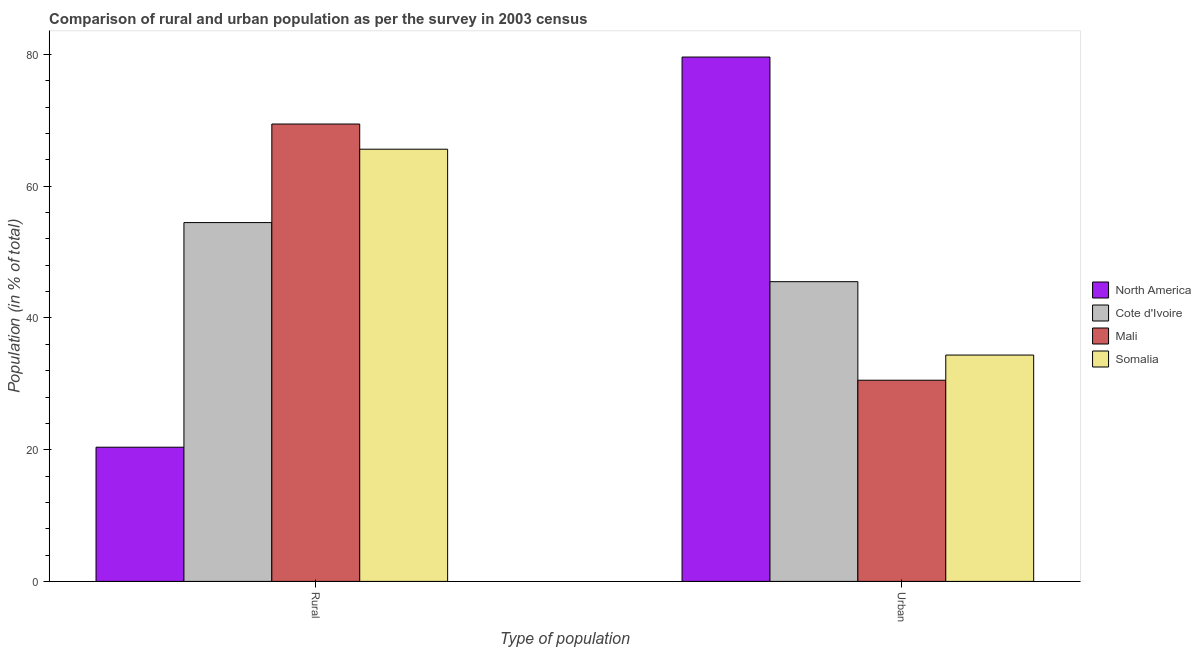Are the number of bars per tick equal to the number of legend labels?
Make the answer very short. Yes. Are the number of bars on each tick of the X-axis equal?
Make the answer very short. Yes. How many bars are there on the 1st tick from the left?
Your answer should be compact. 4. What is the label of the 2nd group of bars from the left?
Your answer should be very brief. Urban. What is the rural population in Cote d'Ivoire?
Provide a short and direct response. 54.49. Across all countries, what is the maximum rural population?
Provide a short and direct response. 69.45. Across all countries, what is the minimum urban population?
Give a very brief answer. 30.55. In which country was the rural population maximum?
Make the answer very short. Mali. In which country was the rural population minimum?
Provide a succinct answer. North America. What is the total rural population in the graph?
Provide a succinct answer. 209.94. What is the difference between the rural population in Mali and that in North America?
Provide a succinct answer. 49.08. What is the difference between the rural population in North America and the urban population in Mali?
Make the answer very short. -10.17. What is the average rural population per country?
Keep it short and to the point. 52.49. What is the difference between the rural population and urban population in Mali?
Your answer should be compact. 38.91. In how many countries, is the rural population greater than 48 %?
Provide a short and direct response. 3. What is the ratio of the urban population in Mali to that in Somalia?
Your response must be concise. 0.89. Is the rural population in Somalia less than that in Mali?
Make the answer very short. Yes. In how many countries, is the rural population greater than the average rural population taken over all countries?
Provide a succinct answer. 3. What does the 1st bar from the right in Urban represents?
Your answer should be very brief. Somalia. How many countries are there in the graph?
Ensure brevity in your answer.  4. What is the difference between two consecutive major ticks on the Y-axis?
Offer a terse response. 20. Does the graph contain any zero values?
Keep it short and to the point. No. What is the title of the graph?
Your answer should be compact. Comparison of rural and urban population as per the survey in 2003 census. What is the label or title of the X-axis?
Offer a terse response. Type of population. What is the label or title of the Y-axis?
Your response must be concise. Population (in % of total). What is the Population (in % of total) in North America in Rural?
Offer a terse response. 20.38. What is the Population (in % of total) in Cote d'Ivoire in Rural?
Offer a very short reply. 54.49. What is the Population (in % of total) in Mali in Rural?
Keep it short and to the point. 69.45. What is the Population (in % of total) in Somalia in Rural?
Make the answer very short. 65.63. What is the Population (in % of total) of North America in Urban?
Offer a terse response. 79.62. What is the Population (in % of total) in Cote d'Ivoire in Urban?
Offer a terse response. 45.51. What is the Population (in % of total) in Mali in Urban?
Your response must be concise. 30.55. What is the Population (in % of total) in Somalia in Urban?
Your answer should be very brief. 34.37. Across all Type of population, what is the maximum Population (in % of total) in North America?
Give a very brief answer. 79.62. Across all Type of population, what is the maximum Population (in % of total) in Cote d'Ivoire?
Provide a short and direct response. 54.49. Across all Type of population, what is the maximum Population (in % of total) of Mali?
Ensure brevity in your answer.  69.45. Across all Type of population, what is the maximum Population (in % of total) of Somalia?
Ensure brevity in your answer.  65.63. Across all Type of population, what is the minimum Population (in % of total) of North America?
Keep it short and to the point. 20.38. Across all Type of population, what is the minimum Population (in % of total) in Cote d'Ivoire?
Your response must be concise. 45.51. Across all Type of population, what is the minimum Population (in % of total) in Mali?
Provide a short and direct response. 30.55. Across all Type of population, what is the minimum Population (in % of total) of Somalia?
Offer a very short reply. 34.37. What is the total Population (in % of total) of North America in the graph?
Keep it short and to the point. 100. What is the total Population (in % of total) in Cote d'Ivoire in the graph?
Provide a succinct answer. 100. What is the total Population (in % of total) in Mali in the graph?
Ensure brevity in your answer.  100. What is the difference between the Population (in % of total) in North America in Rural and that in Urban?
Provide a short and direct response. -59.25. What is the difference between the Population (in % of total) in Cote d'Ivoire in Rural and that in Urban?
Give a very brief answer. 8.97. What is the difference between the Population (in % of total) in Mali in Rural and that in Urban?
Ensure brevity in your answer.  38.91. What is the difference between the Population (in % of total) of Somalia in Rural and that in Urban?
Offer a terse response. 31.26. What is the difference between the Population (in % of total) in North America in Rural and the Population (in % of total) in Cote d'Ivoire in Urban?
Offer a terse response. -25.14. What is the difference between the Population (in % of total) in North America in Rural and the Population (in % of total) in Mali in Urban?
Provide a succinct answer. -10.17. What is the difference between the Population (in % of total) of North America in Rural and the Population (in % of total) of Somalia in Urban?
Your answer should be very brief. -14. What is the difference between the Population (in % of total) of Cote d'Ivoire in Rural and the Population (in % of total) of Mali in Urban?
Make the answer very short. 23.94. What is the difference between the Population (in % of total) of Cote d'Ivoire in Rural and the Population (in % of total) of Somalia in Urban?
Ensure brevity in your answer.  20.12. What is the difference between the Population (in % of total) in Mali in Rural and the Population (in % of total) in Somalia in Urban?
Ensure brevity in your answer.  35.08. What is the average Population (in % of total) of North America per Type of population?
Offer a very short reply. 50. What is the average Population (in % of total) of Cote d'Ivoire per Type of population?
Make the answer very short. 50. What is the average Population (in % of total) of Mali per Type of population?
Your response must be concise. 50. What is the average Population (in % of total) of Somalia per Type of population?
Offer a terse response. 50. What is the difference between the Population (in % of total) of North America and Population (in % of total) of Cote d'Ivoire in Rural?
Offer a very short reply. -34.11. What is the difference between the Population (in % of total) of North America and Population (in % of total) of Mali in Rural?
Your response must be concise. -49.08. What is the difference between the Population (in % of total) of North America and Population (in % of total) of Somalia in Rural?
Keep it short and to the point. -45.25. What is the difference between the Population (in % of total) in Cote d'Ivoire and Population (in % of total) in Mali in Rural?
Make the answer very short. -14.97. What is the difference between the Population (in % of total) in Cote d'Ivoire and Population (in % of total) in Somalia in Rural?
Provide a short and direct response. -11.14. What is the difference between the Population (in % of total) of Mali and Population (in % of total) of Somalia in Rural?
Provide a short and direct response. 3.82. What is the difference between the Population (in % of total) of North America and Population (in % of total) of Cote d'Ivoire in Urban?
Provide a succinct answer. 34.11. What is the difference between the Population (in % of total) in North America and Population (in % of total) in Mali in Urban?
Your answer should be very brief. 49.08. What is the difference between the Population (in % of total) in North America and Population (in % of total) in Somalia in Urban?
Give a very brief answer. 45.25. What is the difference between the Population (in % of total) of Cote d'Ivoire and Population (in % of total) of Mali in Urban?
Make the answer very short. 14.97. What is the difference between the Population (in % of total) in Cote d'Ivoire and Population (in % of total) in Somalia in Urban?
Provide a succinct answer. 11.14. What is the difference between the Population (in % of total) in Mali and Population (in % of total) in Somalia in Urban?
Provide a succinct answer. -3.82. What is the ratio of the Population (in % of total) of North America in Rural to that in Urban?
Provide a short and direct response. 0.26. What is the ratio of the Population (in % of total) in Cote d'Ivoire in Rural to that in Urban?
Give a very brief answer. 1.2. What is the ratio of the Population (in % of total) in Mali in Rural to that in Urban?
Provide a succinct answer. 2.27. What is the ratio of the Population (in % of total) in Somalia in Rural to that in Urban?
Ensure brevity in your answer.  1.91. What is the difference between the highest and the second highest Population (in % of total) in North America?
Ensure brevity in your answer.  59.25. What is the difference between the highest and the second highest Population (in % of total) of Cote d'Ivoire?
Provide a short and direct response. 8.97. What is the difference between the highest and the second highest Population (in % of total) of Mali?
Your answer should be very brief. 38.91. What is the difference between the highest and the second highest Population (in % of total) of Somalia?
Ensure brevity in your answer.  31.26. What is the difference between the highest and the lowest Population (in % of total) in North America?
Make the answer very short. 59.25. What is the difference between the highest and the lowest Population (in % of total) of Cote d'Ivoire?
Your response must be concise. 8.97. What is the difference between the highest and the lowest Population (in % of total) in Mali?
Your response must be concise. 38.91. What is the difference between the highest and the lowest Population (in % of total) of Somalia?
Your response must be concise. 31.26. 